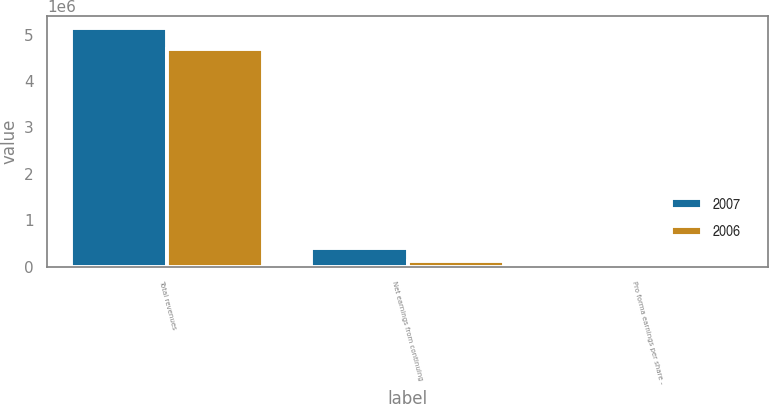<chart> <loc_0><loc_0><loc_500><loc_500><stacked_bar_chart><ecel><fcel>Total revenues<fcel>Net earnings from continuing<fcel>Pro forma earnings per share -<nl><fcel>2007<fcel>5.14372e+06<fcel>400213<fcel>2.04<nl><fcel>2006<fcel>4.68749e+06<fcel>127505<fcel>0.65<nl></chart> 